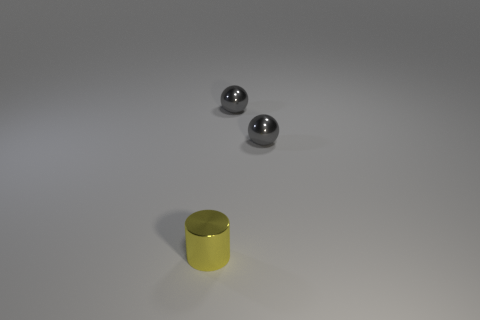Add 1 tiny yellow metallic cylinders. How many objects exist? 4 Subtract 2 spheres. How many spheres are left? 0 Subtract all cylinders. How many objects are left? 2 Subtract all cyan balls. Subtract all yellow cubes. How many balls are left? 2 Add 1 cyan cubes. How many cyan cubes exist? 1 Subtract 0 gray cylinders. How many objects are left? 3 Subtract all purple cubes. How many gray cylinders are left? 0 Subtract all tiny things. Subtract all matte things. How many objects are left? 0 Add 1 gray metal balls. How many gray metal balls are left? 3 